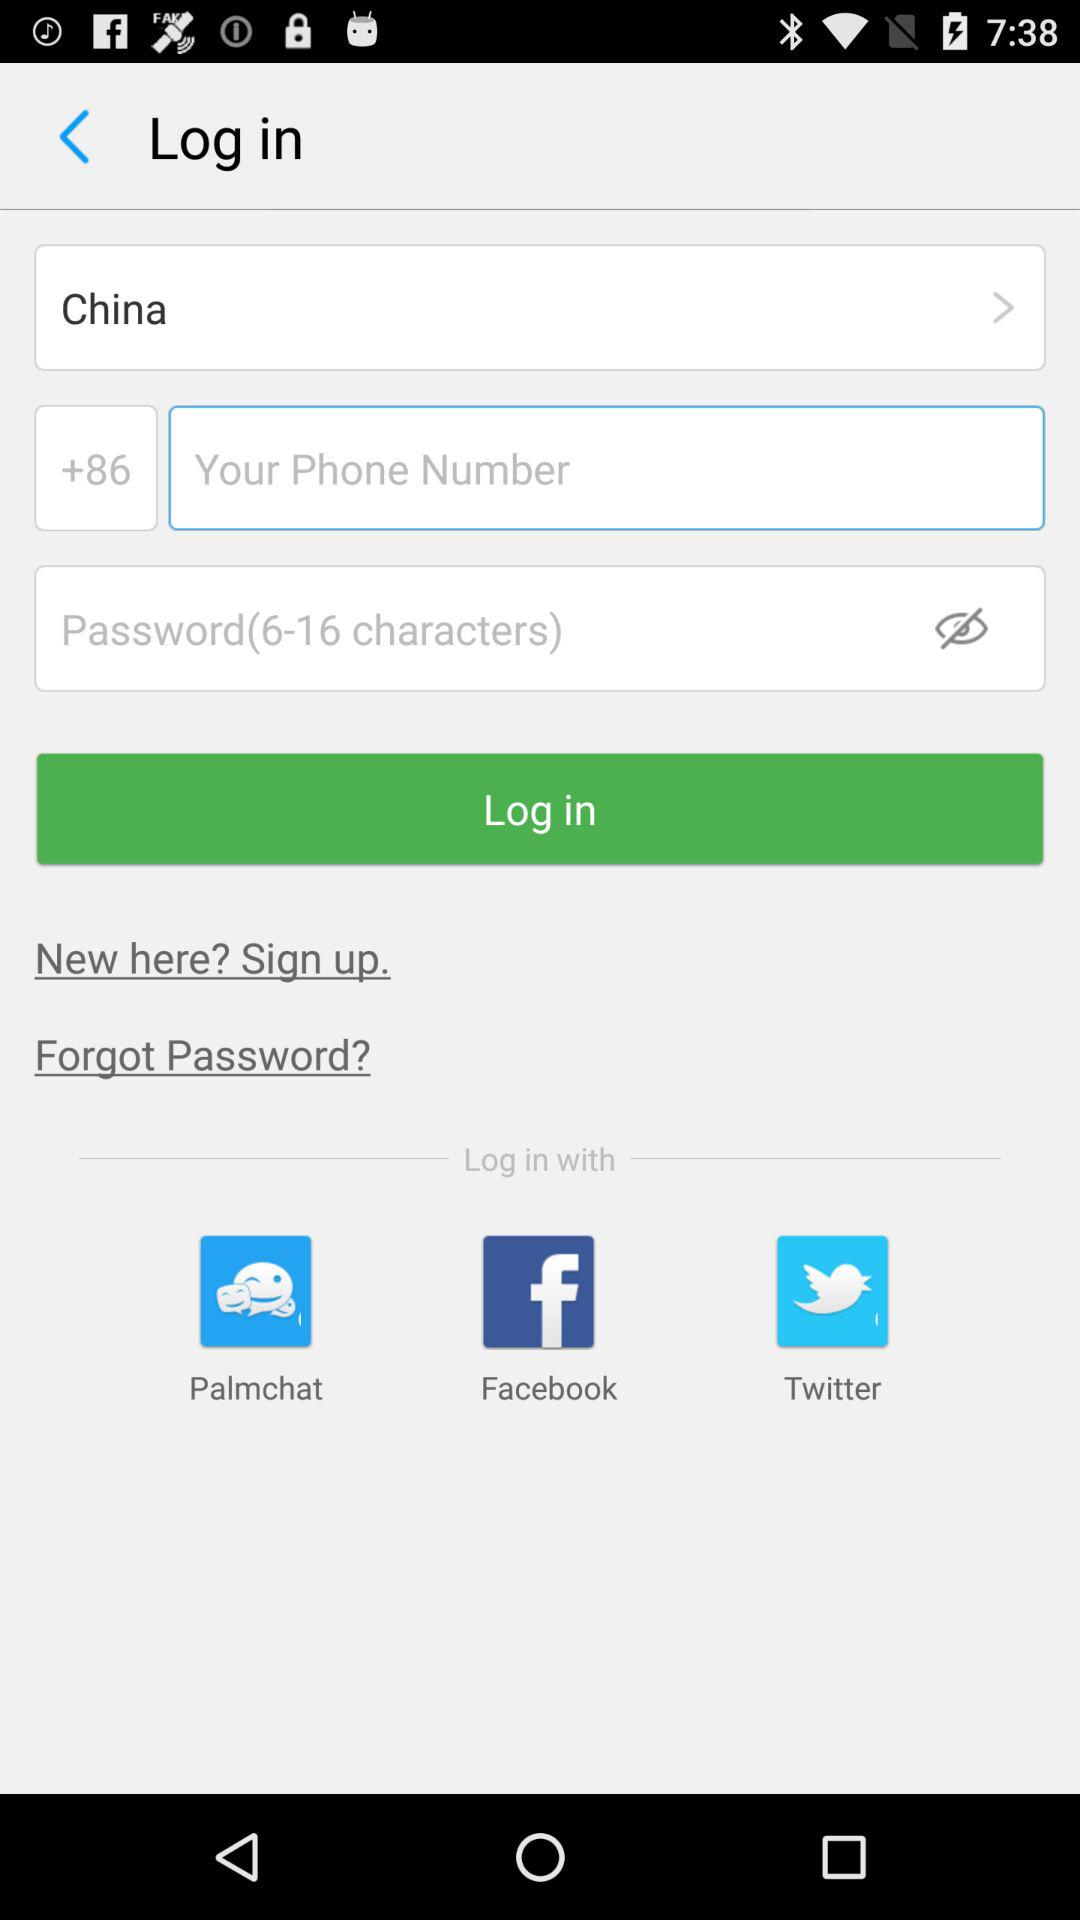What should be the length of the password in terms of characters? The length of the password should be 6–16 characters. 